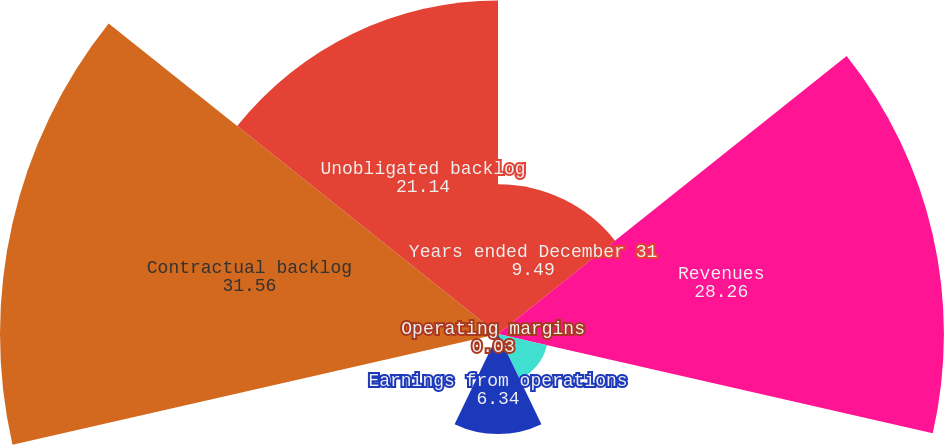<chart> <loc_0><loc_0><loc_500><loc_500><pie_chart><fcel>Years ended December 31<fcel>Revenues<fcel>of total company revenues<fcel>Earnings from operations<fcel>Operating margins<fcel>Contractual backlog<fcel>Unobligated backlog<nl><fcel>9.49%<fcel>28.26%<fcel>3.18%<fcel>6.34%<fcel>0.03%<fcel>31.56%<fcel>21.14%<nl></chart> 